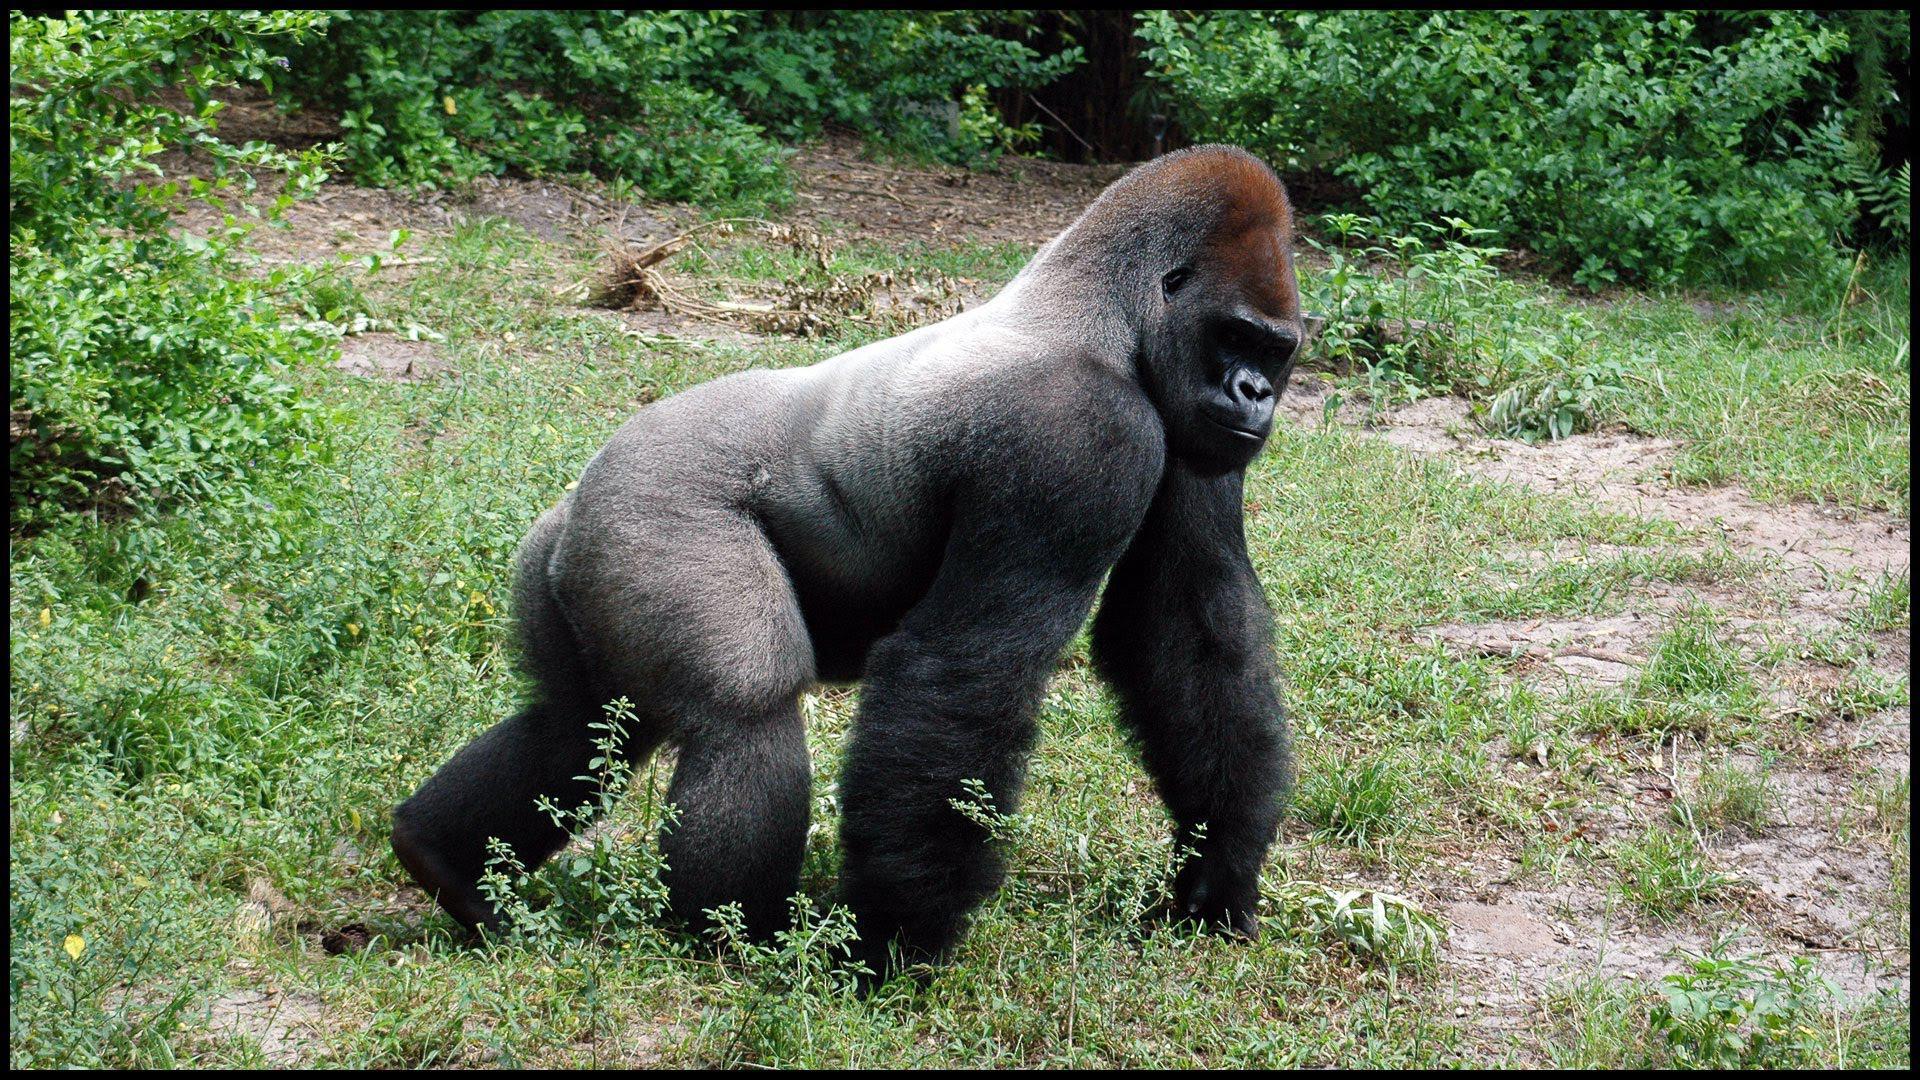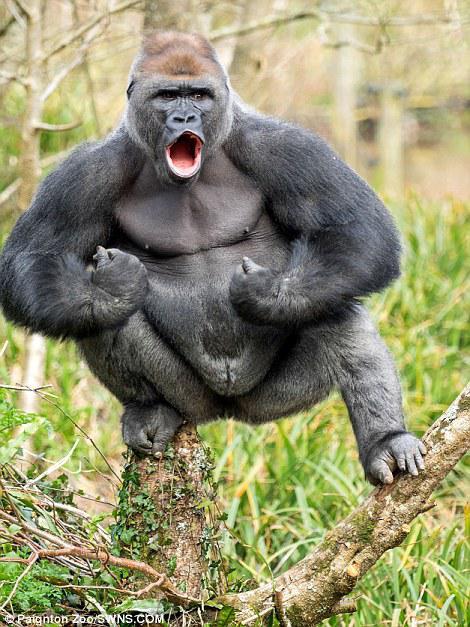The first image is the image on the left, the second image is the image on the right. Analyze the images presented: Is the assertion "There is at least one monkey standing on all four paws." valid? Answer yes or no. Yes. The first image is the image on the left, the second image is the image on the right. Given the left and right images, does the statement "The gorilla in the image on the right is standing completely upright." hold true? Answer yes or no. No. 